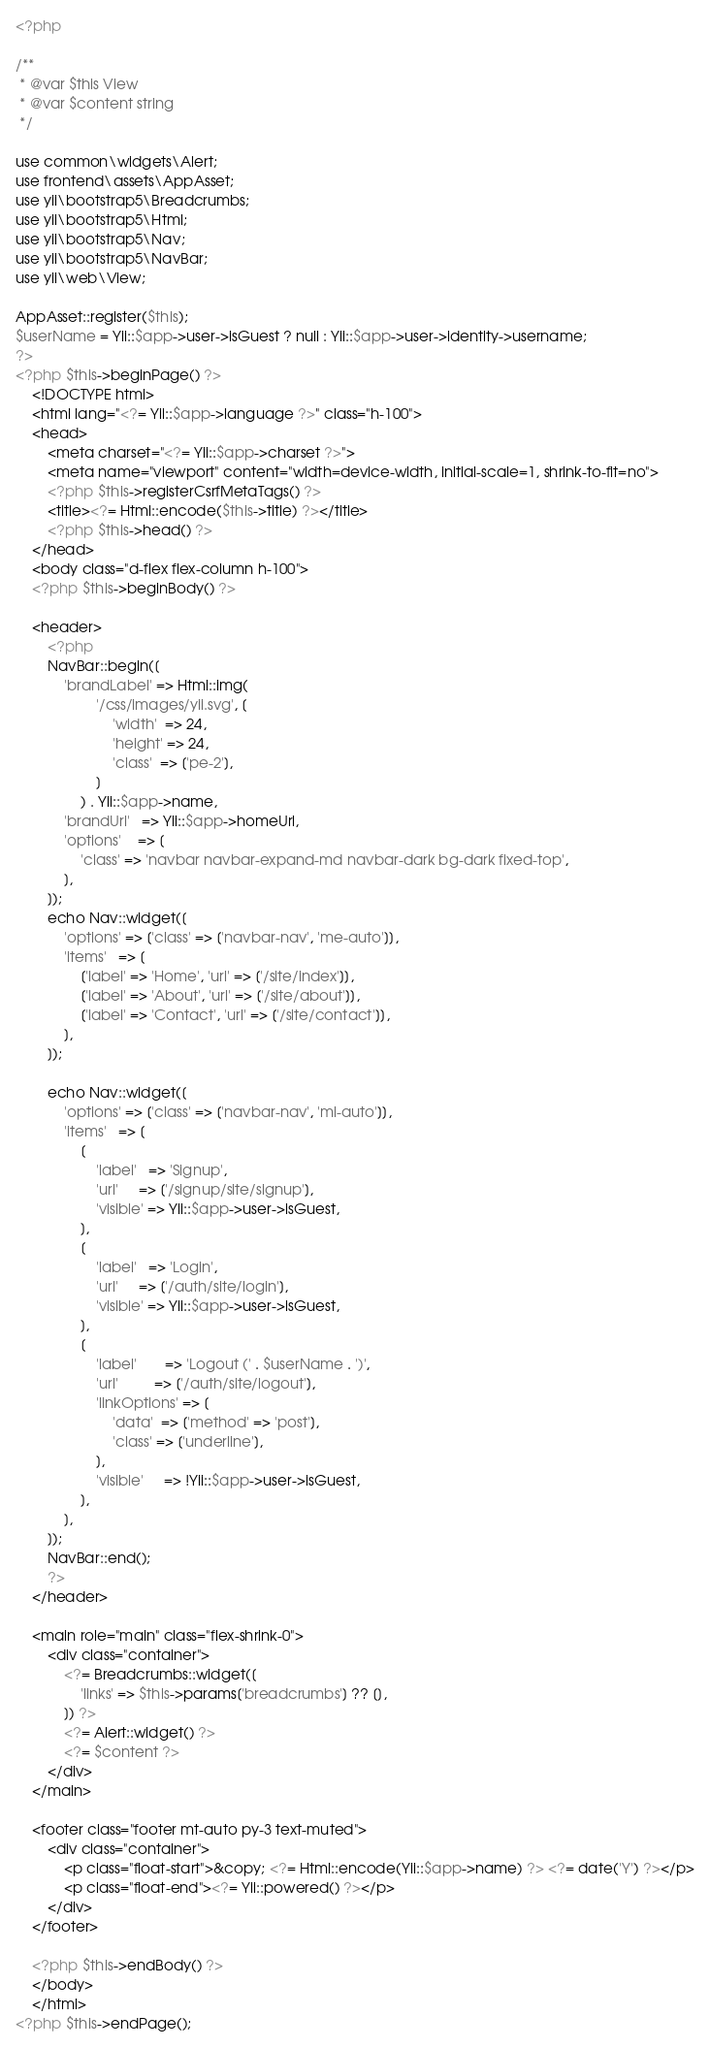<code> <loc_0><loc_0><loc_500><loc_500><_PHP_><?php

/**
 * @var $this View
 * @var $content string
 */

use common\widgets\Alert;
use frontend\assets\AppAsset;
use yii\bootstrap5\Breadcrumbs;
use yii\bootstrap5\Html;
use yii\bootstrap5\Nav;
use yii\bootstrap5\NavBar;
use yii\web\View;

AppAsset::register($this);
$userName = Yii::$app->user->isGuest ? null : Yii::$app->user->identity->username;
?>
<?php $this->beginPage() ?>
    <!DOCTYPE html>
    <html lang="<?= Yii::$app->language ?>" class="h-100">
    <head>
        <meta charset="<?= Yii::$app->charset ?>">
        <meta name="viewport" content="width=device-width, initial-scale=1, shrink-to-fit=no">
        <?php $this->registerCsrfMetaTags() ?>
        <title><?= Html::encode($this->title) ?></title>
        <?php $this->head() ?>
    </head>
    <body class="d-flex flex-column h-100">
    <?php $this->beginBody() ?>

    <header>
        <?php
        NavBar::begin([
            'brandLabel' => Html::img(
                    '/css/images/yii.svg', [
                        'width'  => 24,
                        'height' => 24,
                        'class'  => ['pe-2'],
                    ]
                ) . Yii::$app->name,
            'brandUrl'   => Yii::$app->homeUrl,
            'options'    => [
                'class' => 'navbar navbar-expand-md navbar-dark bg-dark fixed-top',
            ],
        ]);
        echo Nav::widget([
            'options' => ['class' => ['navbar-nav', 'me-auto']],
            'items'   => [
                ['label' => 'Home', 'url' => ['/site/index']],
                ['label' => 'About', 'url' => ['/site/about']],
                ['label' => 'Contact', 'url' => ['/site/contact']],
            ],
        ]);

        echo Nav::widget([
            'options' => ['class' => ['navbar-nav', 'ml-auto']],
            'items'   => [
                [
                    'label'   => 'Signup',
                    'url'     => ['/signup/site/signup'],
                    'visible' => Yii::$app->user->isGuest,
                ],
                [
                    'label'   => 'Login',
                    'url'     => ['/auth/site/login'],
                    'visible' => Yii::$app->user->isGuest,
                ],
                [
                    'label'       => 'Logout (' . $userName . ')',
                    'url'         => ['/auth/site/logout'],
                    'linkOptions' => [
                        'data'  => ['method' => 'post'],
                        'class' => ['underline'],
                    ],
                    'visible'     => !Yii::$app->user->isGuest,
                ],
            ],
        ]);
        NavBar::end();
        ?>
    </header>

    <main role="main" class="flex-shrink-0">
        <div class="container">
            <?= Breadcrumbs::widget([
                'links' => $this->params['breadcrumbs'] ?? [],
            ]) ?>
            <?= Alert::widget() ?>
            <?= $content ?>
        </div>
    </main>

    <footer class="footer mt-auto py-3 text-muted">
        <div class="container">
            <p class="float-start">&copy; <?= Html::encode(Yii::$app->name) ?> <?= date('Y') ?></p>
            <p class="float-end"><?= Yii::powered() ?></p>
        </div>
    </footer>

    <?php $this->endBody() ?>
    </body>
    </html>
<?php $this->endPage();
</code> 